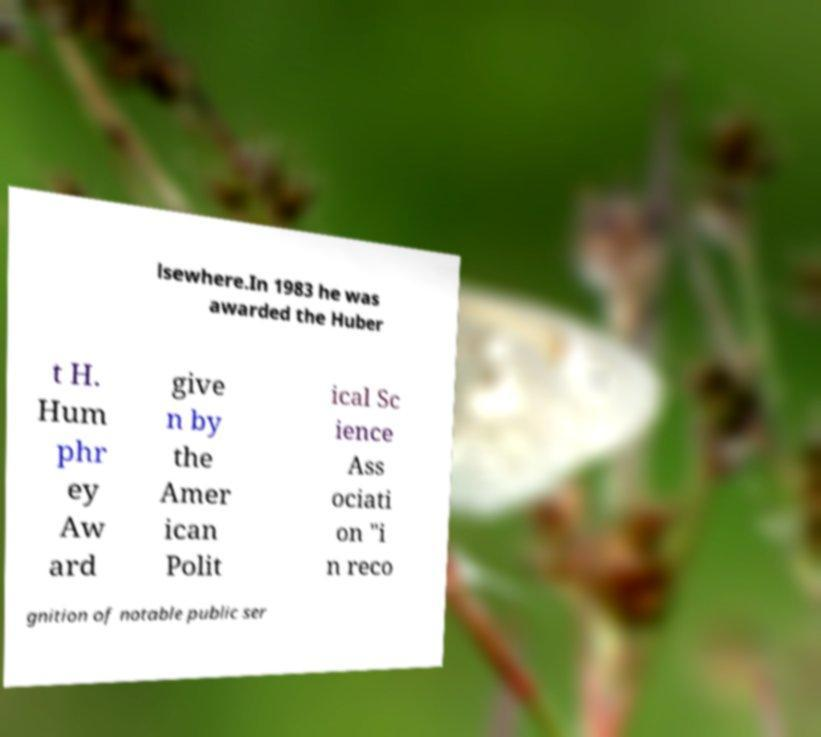Can you read and provide the text displayed in the image?This photo seems to have some interesting text. Can you extract and type it out for me? lsewhere.In 1983 he was awarded the Huber t H. Hum phr ey Aw ard give n by the Amer ican Polit ical Sc ience Ass ociati on "i n reco gnition of notable public ser 